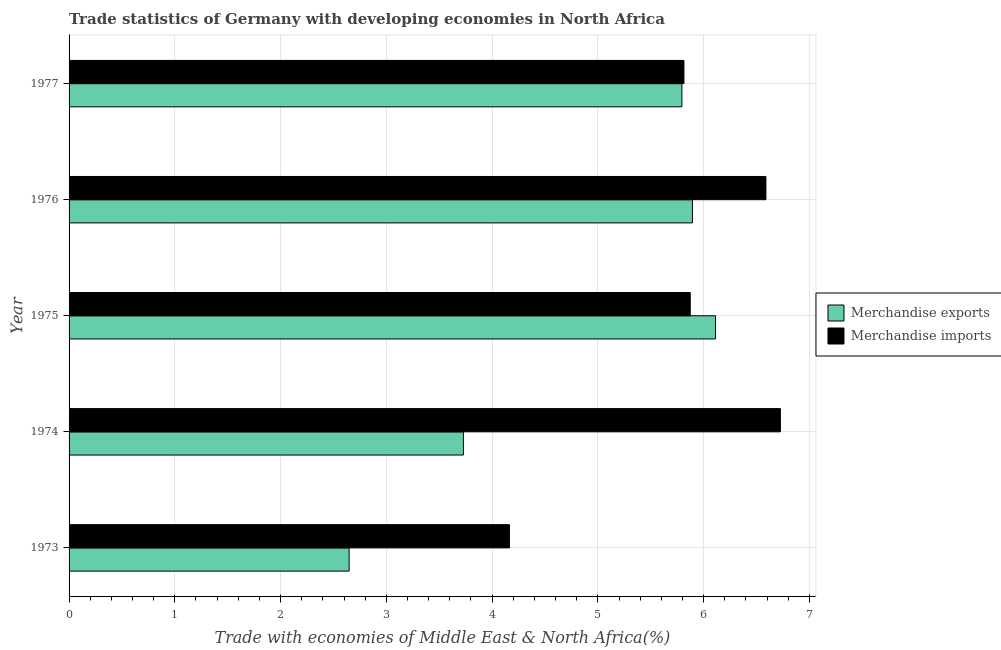How many groups of bars are there?
Ensure brevity in your answer.  5. Are the number of bars per tick equal to the number of legend labels?
Your answer should be compact. Yes. Are the number of bars on each tick of the Y-axis equal?
Keep it short and to the point. Yes. What is the label of the 4th group of bars from the top?
Your response must be concise. 1974. What is the merchandise exports in 1976?
Keep it short and to the point. 5.89. Across all years, what is the maximum merchandise exports?
Give a very brief answer. 6.11. Across all years, what is the minimum merchandise exports?
Ensure brevity in your answer.  2.65. In which year was the merchandise imports maximum?
Make the answer very short. 1974. What is the total merchandise exports in the graph?
Offer a terse response. 24.18. What is the difference between the merchandise imports in 1976 and that in 1977?
Provide a succinct answer. 0.78. What is the difference between the merchandise exports in 1977 and the merchandise imports in 1974?
Offer a very short reply. -0.93. What is the average merchandise imports per year?
Offer a very short reply. 5.83. In the year 1974, what is the difference between the merchandise imports and merchandise exports?
Make the answer very short. 3. In how many years, is the merchandise imports greater than 0.6000000000000001 %?
Give a very brief answer. 5. Is the merchandise exports in 1976 less than that in 1977?
Keep it short and to the point. No. What is the difference between the highest and the second highest merchandise imports?
Give a very brief answer. 0.14. What is the difference between the highest and the lowest merchandise exports?
Offer a very short reply. 3.46. How many bars are there?
Ensure brevity in your answer.  10. What is the difference between two consecutive major ticks on the X-axis?
Make the answer very short. 1. Are the values on the major ticks of X-axis written in scientific E-notation?
Your answer should be compact. No. Where does the legend appear in the graph?
Your answer should be very brief. Center right. How many legend labels are there?
Your response must be concise. 2. What is the title of the graph?
Your answer should be compact. Trade statistics of Germany with developing economies in North Africa. What is the label or title of the X-axis?
Your answer should be very brief. Trade with economies of Middle East & North Africa(%). What is the Trade with economies of Middle East & North Africa(%) of Merchandise exports in 1973?
Offer a terse response. 2.65. What is the Trade with economies of Middle East & North Africa(%) of Merchandise imports in 1973?
Offer a very short reply. 4.16. What is the Trade with economies of Middle East & North Africa(%) of Merchandise exports in 1974?
Your answer should be very brief. 3.73. What is the Trade with economies of Middle East & North Africa(%) of Merchandise imports in 1974?
Make the answer very short. 6.73. What is the Trade with economies of Middle East & North Africa(%) of Merchandise exports in 1975?
Your answer should be compact. 6.11. What is the Trade with economies of Middle East & North Africa(%) in Merchandise imports in 1975?
Offer a very short reply. 5.87. What is the Trade with economies of Middle East & North Africa(%) in Merchandise exports in 1976?
Make the answer very short. 5.89. What is the Trade with economies of Middle East & North Africa(%) of Merchandise imports in 1976?
Offer a very short reply. 6.59. What is the Trade with economies of Middle East & North Africa(%) of Merchandise exports in 1977?
Give a very brief answer. 5.79. What is the Trade with economies of Middle East & North Africa(%) of Merchandise imports in 1977?
Your answer should be compact. 5.81. Across all years, what is the maximum Trade with economies of Middle East & North Africa(%) in Merchandise exports?
Provide a short and direct response. 6.11. Across all years, what is the maximum Trade with economies of Middle East & North Africa(%) in Merchandise imports?
Offer a terse response. 6.73. Across all years, what is the minimum Trade with economies of Middle East & North Africa(%) of Merchandise exports?
Offer a terse response. 2.65. Across all years, what is the minimum Trade with economies of Middle East & North Africa(%) of Merchandise imports?
Keep it short and to the point. 4.16. What is the total Trade with economies of Middle East & North Africa(%) of Merchandise exports in the graph?
Provide a succinct answer. 24.18. What is the total Trade with economies of Middle East & North Africa(%) of Merchandise imports in the graph?
Give a very brief answer. 29.16. What is the difference between the Trade with economies of Middle East & North Africa(%) in Merchandise exports in 1973 and that in 1974?
Keep it short and to the point. -1.08. What is the difference between the Trade with economies of Middle East & North Africa(%) of Merchandise imports in 1973 and that in 1974?
Make the answer very short. -2.56. What is the difference between the Trade with economies of Middle East & North Africa(%) of Merchandise exports in 1973 and that in 1975?
Offer a terse response. -3.46. What is the difference between the Trade with economies of Middle East & North Africa(%) in Merchandise imports in 1973 and that in 1975?
Provide a short and direct response. -1.71. What is the difference between the Trade with economies of Middle East & North Africa(%) in Merchandise exports in 1973 and that in 1976?
Your response must be concise. -3.25. What is the difference between the Trade with economies of Middle East & North Africa(%) in Merchandise imports in 1973 and that in 1976?
Your answer should be compact. -2.43. What is the difference between the Trade with economies of Middle East & North Africa(%) in Merchandise exports in 1973 and that in 1977?
Ensure brevity in your answer.  -3.15. What is the difference between the Trade with economies of Middle East & North Africa(%) of Merchandise imports in 1973 and that in 1977?
Offer a very short reply. -1.65. What is the difference between the Trade with economies of Middle East & North Africa(%) of Merchandise exports in 1974 and that in 1975?
Ensure brevity in your answer.  -2.38. What is the difference between the Trade with economies of Middle East & North Africa(%) in Merchandise imports in 1974 and that in 1975?
Make the answer very short. 0.85. What is the difference between the Trade with economies of Middle East & North Africa(%) of Merchandise exports in 1974 and that in 1976?
Make the answer very short. -2.17. What is the difference between the Trade with economies of Middle East & North Africa(%) of Merchandise imports in 1974 and that in 1976?
Your answer should be very brief. 0.14. What is the difference between the Trade with economies of Middle East & North Africa(%) of Merchandise exports in 1974 and that in 1977?
Make the answer very short. -2.07. What is the difference between the Trade with economies of Middle East & North Africa(%) in Merchandise imports in 1974 and that in 1977?
Your response must be concise. 0.91. What is the difference between the Trade with economies of Middle East & North Africa(%) of Merchandise exports in 1975 and that in 1976?
Offer a terse response. 0.22. What is the difference between the Trade with economies of Middle East & North Africa(%) in Merchandise imports in 1975 and that in 1976?
Your answer should be very brief. -0.72. What is the difference between the Trade with economies of Middle East & North Africa(%) in Merchandise exports in 1975 and that in 1977?
Make the answer very short. 0.32. What is the difference between the Trade with economies of Middle East & North Africa(%) in Merchandise imports in 1975 and that in 1977?
Keep it short and to the point. 0.06. What is the difference between the Trade with economies of Middle East & North Africa(%) of Merchandise exports in 1976 and that in 1977?
Offer a very short reply. 0.1. What is the difference between the Trade with economies of Middle East & North Africa(%) in Merchandise imports in 1976 and that in 1977?
Ensure brevity in your answer.  0.78. What is the difference between the Trade with economies of Middle East & North Africa(%) in Merchandise exports in 1973 and the Trade with economies of Middle East & North Africa(%) in Merchandise imports in 1974?
Offer a very short reply. -4.08. What is the difference between the Trade with economies of Middle East & North Africa(%) in Merchandise exports in 1973 and the Trade with economies of Middle East & North Africa(%) in Merchandise imports in 1975?
Offer a very short reply. -3.23. What is the difference between the Trade with economies of Middle East & North Africa(%) in Merchandise exports in 1973 and the Trade with economies of Middle East & North Africa(%) in Merchandise imports in 1976?
Provide a succinct answer. -3.94. What is the difference between the Trade with economies of Middle East & North Africa(%) of Merchandise exports in 1973 and the Trade with economies of Middle East & North Africa(%) of Merchandise imports in 1977?
Keep it short and to the point. -3.17. What is the difference between the Trade with economies of Middle East & North Africa(%) of Merchandise exports in 1974 and the Trade with economies of Middle East & North Africa(%) of Merchandise imports in 1975?
Your response must be concise. -2.14. What is the difference between the Trade with economies of Middle East & North Africa(%) of Merchandise exports in 1974 and the Trade with economies of Middle East & North Africa(%) of Merchandise imports in 1976?
Provide a succinct answer. -2.86. What is the difference between the Trade with economies of Middle East & North Africa(%) of Merchandise exports in 1974 and the Trade with economies of Middle East & North Africa(%) of Merchandise imports in 1977?
Ensure brevity in your answer.  -2.08. What is the difference between the Trade with economies of Middle East & North Africa(%) of Merchandise exports in 1975 and the Trade with economies of Middle East & North Africa(%) of Merchandise imports in 1976?
Your response must be concise. -0.48. What is the difference between the Trade with economies of Middle East & North Africa(%) of Merchandise exports in 1975 and the Trade with economies of Middle East & North Africa(%) of Merchandise imports in 1977?
Provide a short and direct response. 0.3. What is the difference between the Trade with economies of Middle East & North Africa(%) in Merchandise exports in 1976 and the Trade with economies of Middle East & North Africa(%) in Merchandise imports in 1977?
Give a very brief answer. 0.08. What is the average Trade with economies of Middle East & North Africa(%) in Merchandise exports per year?
Make the answer very short. 4.84. What is the average Trade with economies of Middle East & North Africa(%) of Merchandise imports per year?
Give a very brief answer. 5.83. In the year 1973, what is the difference between the Trade with economies of Middle East & North Africa(%) of Merchandise exports and Trade with economies of Middle East & North Africa(%) of Merchandise imports?
Your answer should be very brief. -1.52. In the year 1974, what is the difference between the Trade with economies of Middle East & North Africa(%) of Merchandise exports and Trade with economies of Middle East & North Africa(%) of Merchandise imports?
Provide a succinct answer. -3. In the year 1975, what is the difference between the Trade with economies of Middle East & North Africa(%) of Merchandise exports and Trade with economies of Middle East & North Africa(%) of Merchandise imports?
Keep it short and to the point. 0.24. In the year 1976, what is the difference between the Trade with economies of Middle East & North Africa(%) in Merchandise exports and Trade with economies of Middle East & North Africa(%) in Merchandise imports?
Make the answer very short. -0.69. In the year 1977, what is the difference between the Trade with economies of Middle East & North Africa(%) in Merchandise exports and Trade with economies of Middle East & North Africa(%) in Merchandise imports?
Offer a terse response. -0.02. What is the ratio of the Trade with economies of Middle East & North Africa(%) of Merchandise exports in 1973 to that in 1974?
Give a very brief answer. 0.71. What is the ratio of the Trade with economies of Middle East & North Africa(%) in Merchandise imports in 1973 to that in 1974?
Provide a short and direct response. 0.62. What is the ratio of the Trade with economies of Middle East & North Africa(%) of Merchandise exports in 1973 to that in 1975?
Your response must be concise. 0.43. What is the ratio of the Trade with economies of Middle East & North Africa(%) of Merchandise imports in 1973 to that in 1975?
Provide a short and direct response. 0.71. What is the ratio of the Trade with economies of Middle East & North Africa(%) in Merchandise exports in 1973 to that in 1976?
Your answer should be very brief. 0.45. What is the ratio of the Trade with economies of Middle East & North Africa(%) of Merchandise imports in 1973 to that in 1976?
Provide a succinct answer. 0.63. What is the ratio of the Trade with economies of Middle East & North Africa(%) in Merchandise exports in 1973 to that in 1977?
Offer a very short reply. 0.46. What is the ratio of the Trade with economies of Middle East & North Africa(%) in Merchandise imports in 1973 to that in 1977?
Provide a short and direct response. 0.72. What is the ratio of the Trade with economies of Middle East & North Africa(%) in Merchandise exports in 1974 to that in 1975?
Make the answer very short. 0.61. What is the ratio of the Trade with economies of Middle East & North Africa(%) of Merchandise imports in 1974 to that in 1975?
Make the answer very short. 1.15. What is the ratio of the Trade with economies of Middle East & North Africa(%) of Merchandise exports in 1974 to that in 1976?
Keep it short and to the point. 0.63. What is the ratio of the Trade with economies of Middle East & North Africa(%) in Merchandise imports in 1974 to that in 1976?
Offer a very short reply. 1.02. What is the ratio of the Trade with economies of Middle East & North Africa(%) in Merchandise exports in 1974 to that in 1977?
Provide a succinct answer. 0.64. What is the ratio of the Trade with economies of Middle East & North Africa(%) in Merchandise imports in 1974 to that in 1977?
Offer a very short reply. 1.16. What is the ratio of the Trade with economies of Middle East & North Africa(%) in Merchandise exports in 1975 to that in 1976?
Your answer should be compact. 1.04. What is the ratio of the Trade with economies of Middle East & North Africa(%) in Merchandise imports in 1975 to that in 1976?
Provide a succinct answer. 0.89. What is the ratio of the Trade with economies of Middle East & North Africa(%) of Merchandise exports in 1975 to that in 1977?
Give a very brief answer. 1.05. What is the ratio of the Trade with economies of Middle East & North Africa(%) in Merchandise imports in 1975 to that in 1977?
Keep it short and to the point. 1.01. What is the ratio of the Trade with economies of Middle East & North Africa(%) of Merchandise exports in 1976 to that in 1977?
Provide a short and direct response. 1.02. What is the ratio of the Trade with economies of Middle East & North Africa(%) of Merchandise imports in 1976 to that in 1977?
Make the answer very short. 1.13. What is the difference between the highest and the second highest Trade with economies of Middle East & North Africa(%) in Merchandise exports?
Your answer should be compact. 0.22. What is the difference between the highest and the second highest Trade with economies of Middle East & North Africa(%) in Merchandise imports?
Make the answer very short. 0.14. What is the difference between the highest and the lowest Trade with economies of Middle East & North Africa(%) in Merchandise exports?
Your answer should be very brief. 3.46. What is the difference between the highest and the lowest Trade with economies of Middle East & North Africa(%) in Merchandise imports?
Ensure brevity in your answer.  2.56. 